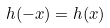Convert formula to latex. <formula><loc_0><loc_0><loc_500><loc_500>h ( - x ) = h ( x )</formula> 